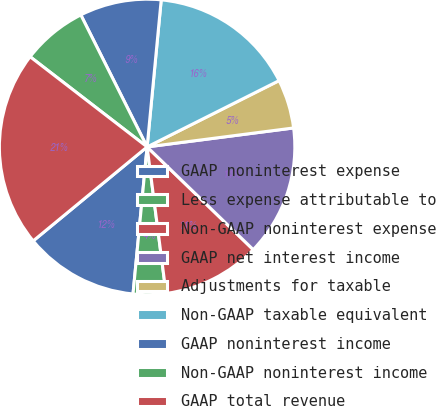<chart> <loc_0><loc_0><loc_500><loc_500><pie_chart><fcel>GAAP noninterest expense<fcel>Less expense attributable to<fcel>Non-GAAP noninterest expense<fcel>GAAP net interest income<fcel>Adjustments for taxable<fcel>Non-GAAP taxable equivalent<fcel>GAAP noninterest income<fcel>Non-GAAP noninterest income<fcel>GAAP total revenue<nl><fcel>12.5%<fcel>3.57%<fcel>10.71%<fcel>14.29%<fcel>5.36%<fcel>16.07%<fcel>8.93%<fcel>7.14%<fcel>21.43%<nl></chart> 